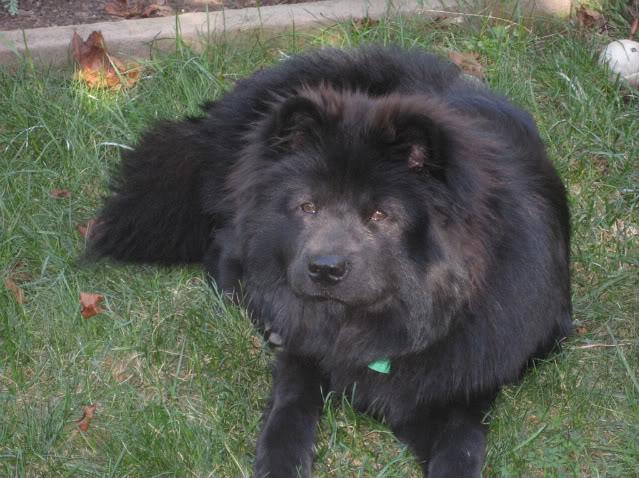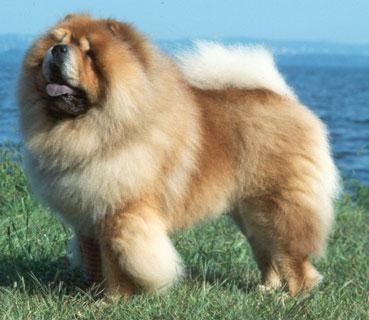The first image is the image on the left, the second image is the image on the right. Examine the images to the left and right. Is the description "Two dogs are standing on the grass" accurate? Answer yes or no. No. 